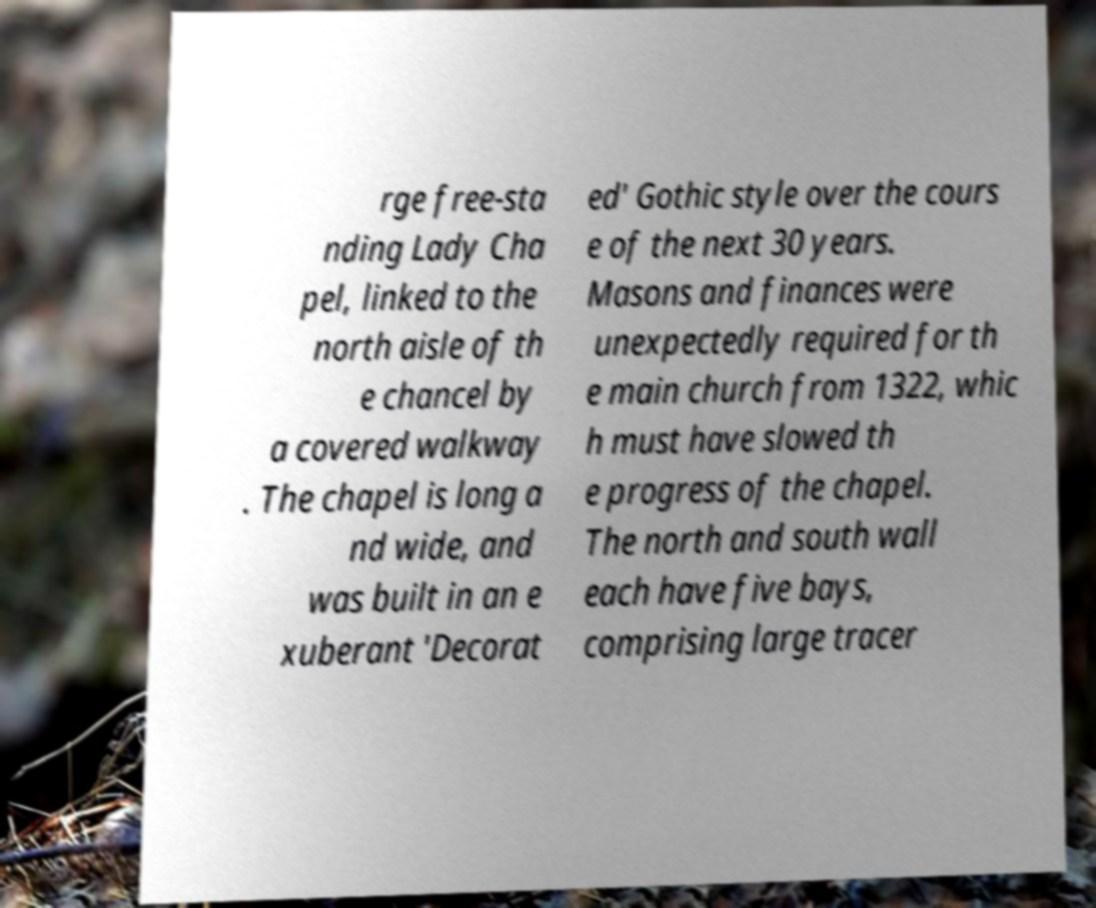Could you assist in decoding the text presented in this image and type it out clearly? rge free-sta nding Lady Cha pel, linked to the north aisle of th e chancel by a covered walkway . The chapel is long a nd wide, and was built in an e xuberant 'Decorat ed' Gothic style over the cours e of the next 30 years. Masons and finances were unexpectedly required for th e main church from 1322, whic h must have slowed th e progress of the chapel. The north and south wall each have five bays, comprising large tracer 